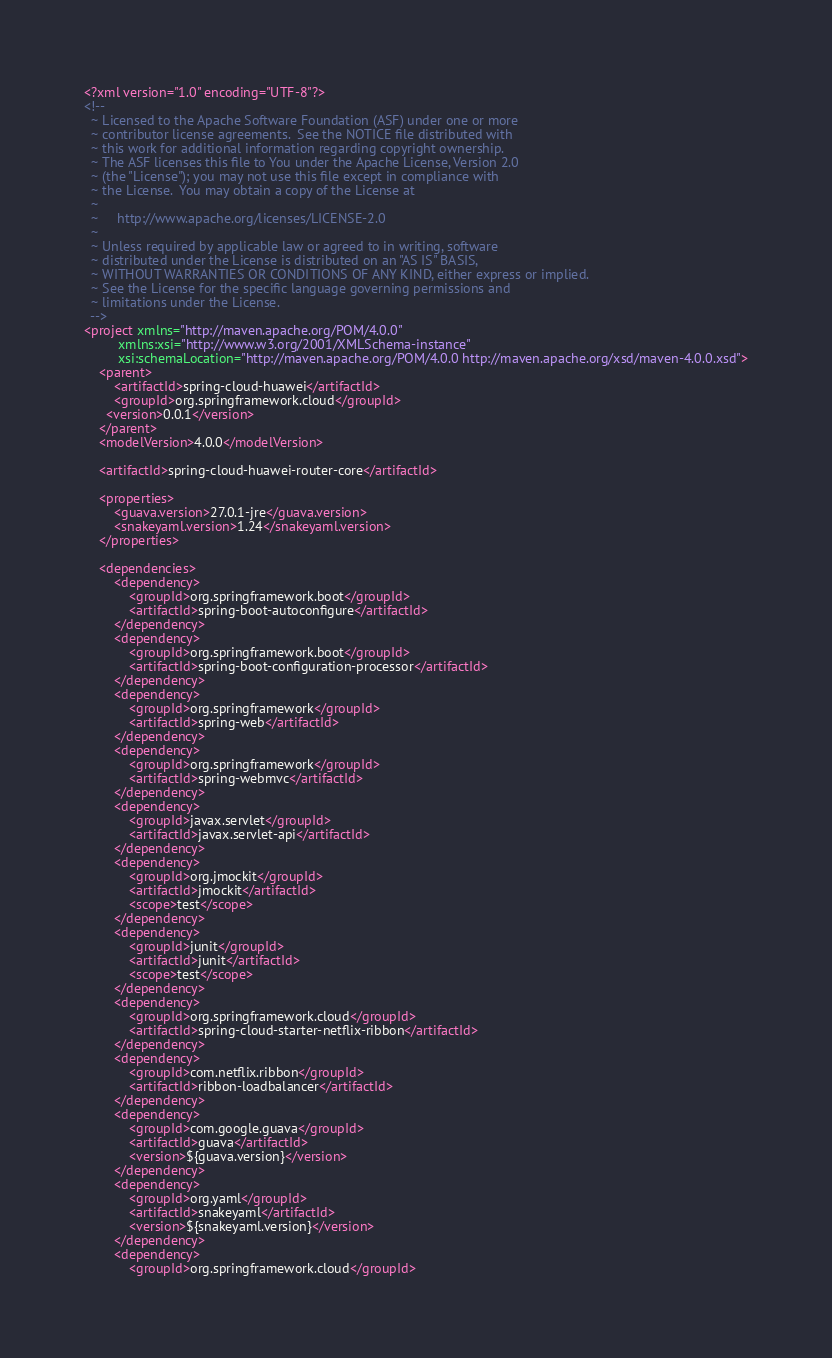<code> <loc_0><loc_0><loc_500><loc_500><_XML_><?xml version="1.0" encoding="UTF-8"?>
<!--
  ~ Licensed to the Apache Software Foundation (ASF) under one or more
  ~ contributor license agreements.  See the NOTICE file distributed with
  ~ this work for additional information regarding copyright ownership.
  ~ The ASF licenses this file to You under the Apache License, Version 2.0
  ~ (the "License"); you may not use this file except in compliance with
  ~ the License.  You may obtain a copy of the License at
  ~
  ~     http://www.apache.org/licenses/LICENSE-2.0
  ~
  ~ Unless required by applicable law or agreed to in writing, software
  ~ distributed under the License is distributed on an "AS IS" BASIS,
  ~ WITHOUT WARRANTIES OR CONDITIONS OF ANY KIND, either express or implied.
  ~ See the License for the specific language governing permissions and
  ~ limitations under the License.
  -->
<project xmlns="http://maven.apache.org/POM/4.0.0"
         xmlns:xsi="http://www.w3.org/2001/XMLSchema-instance"
         xsi:schemaLocation="http://maven.apache.org/POM/4.0.0 http://maven.apache.org/xsd/maven-4.0.0.xsd">
    <parent>
        <artifactId>spring-cloud-huawei</artifactId>
        <groupId>org.springframework.cloud</groupId>
      <version>0.0.1</version>
    </parent>
    <modelVersion>4.0.0</modelVersion>

    <artifactId>spring-cloud-huawei-router-core</artifactId>

    <properties>
        <guava.version>27.0.1-jre</guava.version>
        <snakeyaml.version>1.24</snakeyaml.version>
    </properties>

    <dependencies>
        <dependency>
            <groupId>org.springframework.boot</groupId>
            <artifactId>spring-boot-autoconfigure</artifactId>
        </dependency>
        <dependency>
            <groupId>org.springframework.boot</groupId>
            <artifactId>spring-boot-configuration-processor</artifactId>
        </dependency>
        <dependency>
            <groupId>org.springframework</groupId>
            <artifactId>spring-web</artifactId>
        </dependency>
        <dependency>
            <groupId>org.springframework</groupId>
            <artifactId>spring-webmvc</artifactId>
        </dependency>
        <dependency>
            <groupId>javax.servlet</groupId>
            <artifactId>javax.servlet-api</artifactId>
        </dependency>
        <dependency>
            <groupId>org.jmockit</groupId>
            <artifactId>jmockit</artifactId>
            <scope>test</scope>
        </dependency>
        <dependency>
            <groupId>junit</groupId>
            <artifactId>junit</artifactId>
            <scope>test</scope>
        </dependency>
        <dependency>
            <groupId>org.springframework.cloud</groupId>
            <artifactId>spring-cloud-starter-netflix-ribbon</artifactId>
        </dependency>
        <dependency>
            <groupId>com.netflix.ribbon</groupId>
            <artifactId>ribbon-loadbalancer</artifactId>
        </dependency>
        <dependency>
            <groupId>com.google.guava</groupId>
            <artifactId>guava</artifactId>
            <version>${guava.version}</version>
        </dependency>
        <dependency>
            <groupId>org.yaml</groupId>
            <artifactId>snakeyaml</artifactId>
            <version>${snakeyaml.version}</version>
        </dependency>
        <dependency>
            <groupId>org.springframework.cloud</groupId></code> 